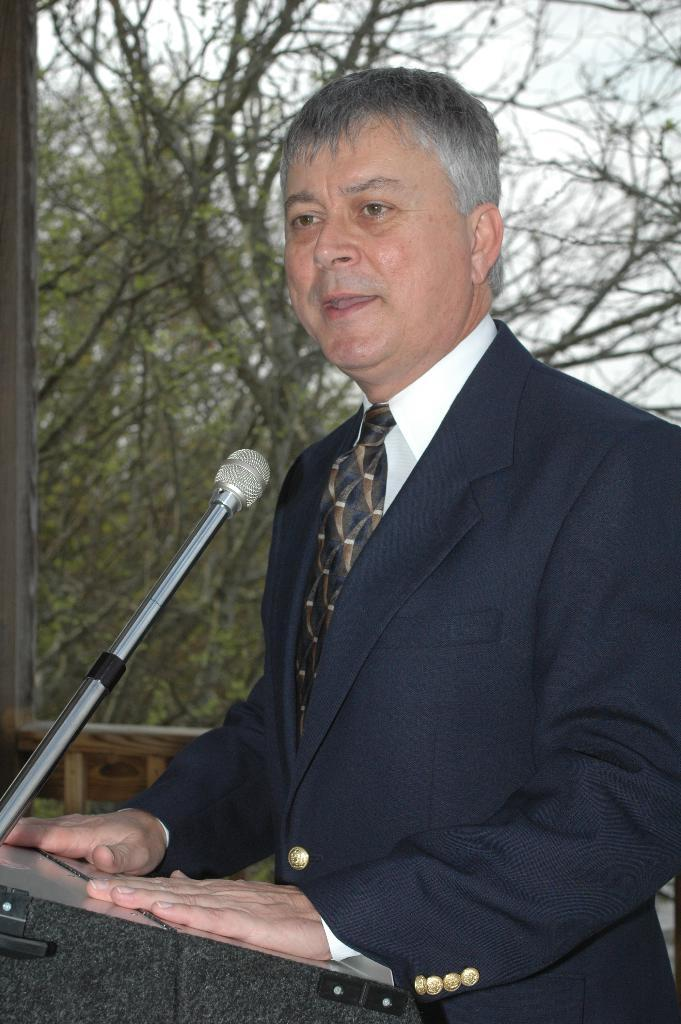What is the person in the image doing? There is a person standing in front of the podium in the image. What is on the podium? There is a mic on the podium. What can be seen in the background of the image? Trees and the sky are visible in the image. How many girls are visible in the image? There is no mention of girls in the image, so we cannot determine their presence or number. 